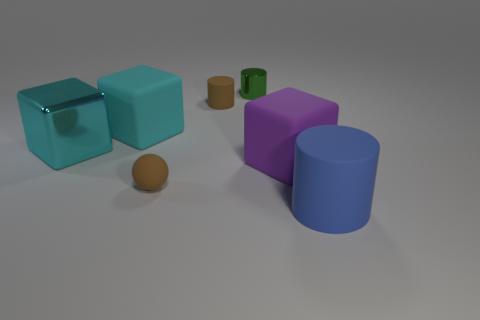Add 3 matte objects. How many objects exist? 10 Subtract all cubes. How many objects are left? 4 Subtract all tiny brown matte things. Subtract all big purple blocks. How many objects are left? 4 Add 7 big purple matte blocks. How many big purple matte blocks are left? 8 Add 3 brown cubes. How many brown cubes exist? 3 Subtract 0 gray cylinders. How many objects are left? 7 